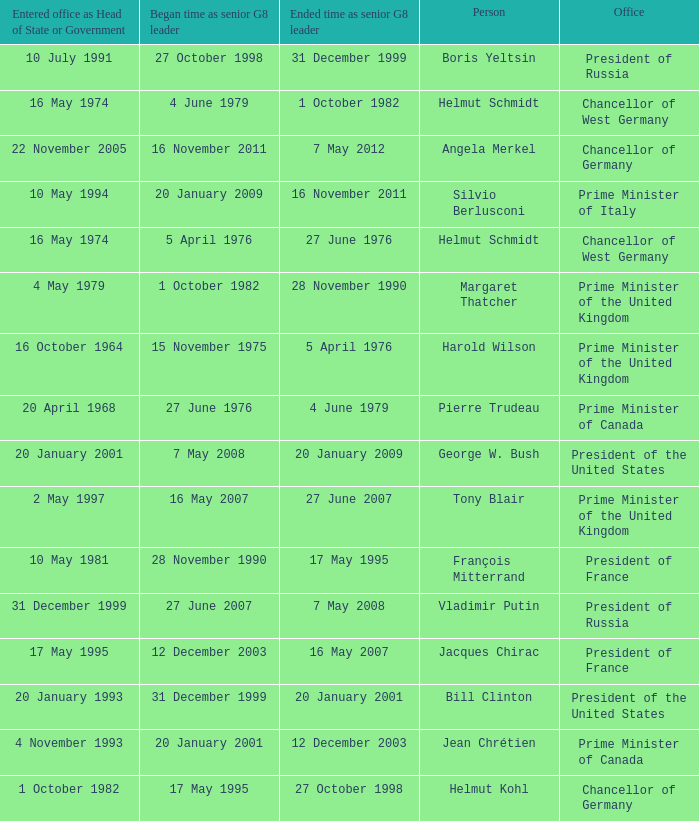When did the Prime Minister of Italy take office? 10 May 1994. 